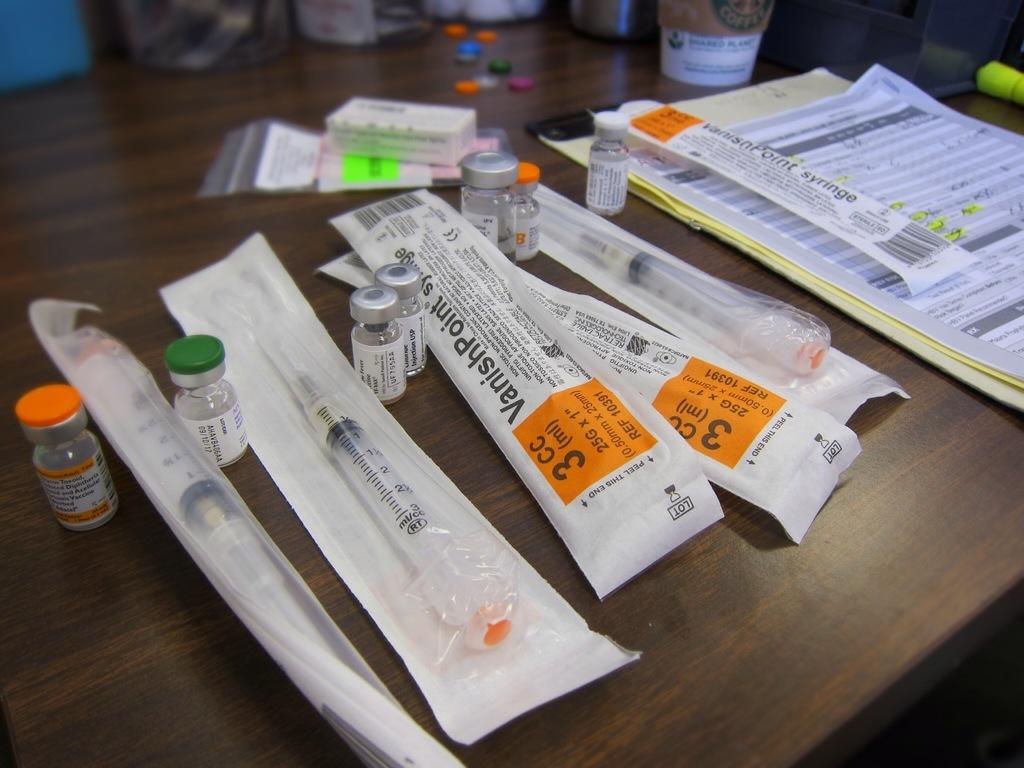<image>
Describe the image concisely. A syringe package goes by the name VanishPoint. 